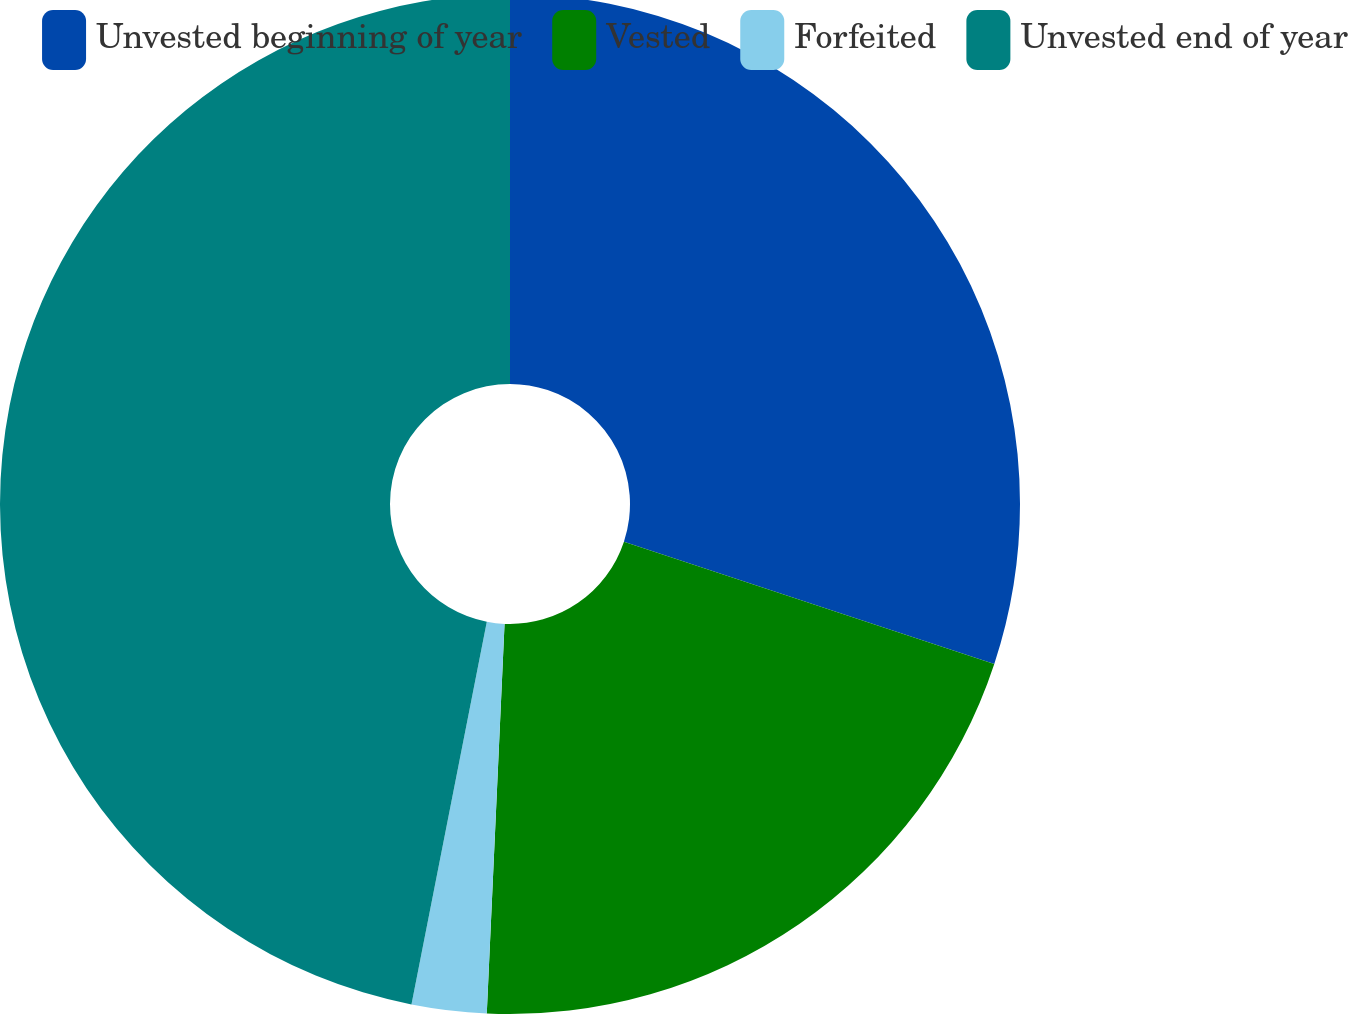<chart> <loc_0><loc_0><loc_500><loc_500><pie_chart><fcel>Unvested beginning of year<fcel>Vested<fcel>Forfeited<fcel>Unvested end of year<nl><fcel>30.08%<fcel>20.65%<fcel>2.37%<fcel>46.91%<nl></chart> 